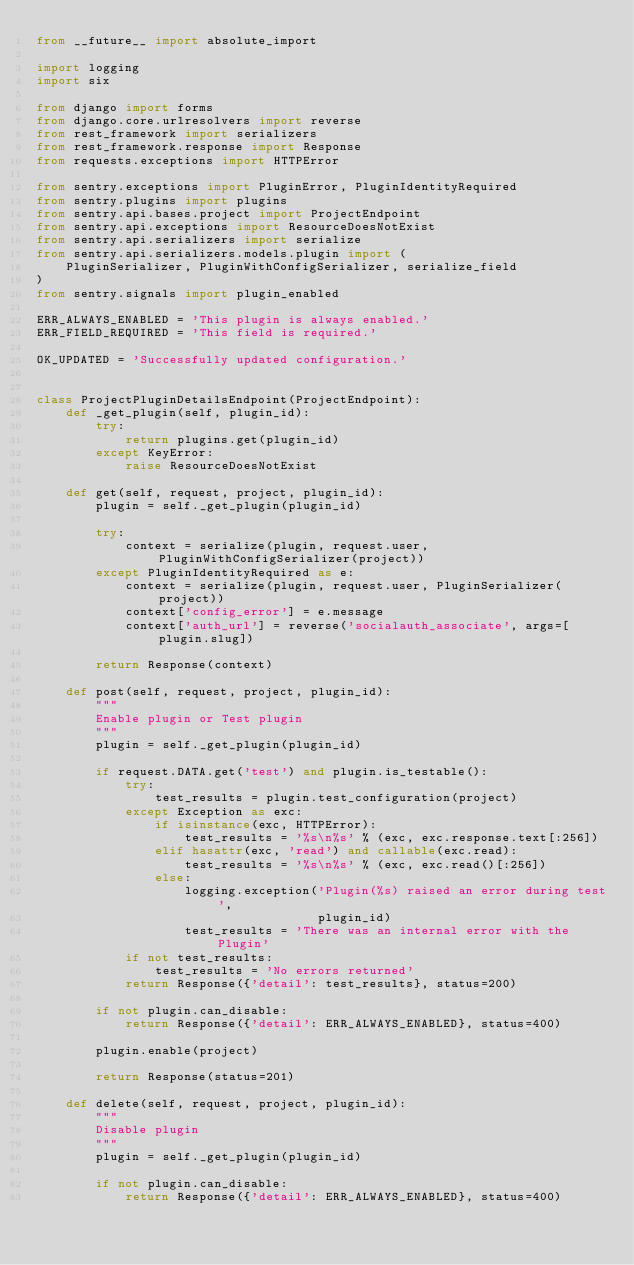<code> <loc_0><loc_0><loc_500><loc_500><_Python_>from __future__ import absolute_import

import logging
import six

from django import forms
from django.core.urlresolvers import reverse
from rest_framework import serializers
from rest_framework.response import Response
from requests.exceptions import HTTPError

from sentry.exceptions import PluginError, PluginIdentityRequired
from sentry.plugins import plugins
from sentry.api.bases.project import ProjectEndpoint
from sentry.api.exceptions import ResourceDoesNotExist
from sentry.api.serializers import serialize
from sentry.api.serializers.models.plugin import (
    PluginSerializer, PluginWithConfigSerializer, serialize_field
)
from sentry.signals import plugin_enabled

ERR_ALWAYS_ENABLED = 'This plugin is always enabled.'
ERR_FIELD_REQUIRED = 'This field is required.'

OK_UPDATED = 'Successfully updated configuration.'


class ProjectPluginDetailsEndpoint(ProjectEndpoint):
    def _get_plugin(self, plugin_id):
        try:
            return plugins.get(plugin_id)
        except KeyError:
            raise ResourceDoesNotExist

    def get(self, request, project, plugin_id):
        plugin = self._get_plugin(plugin_id)

        try:
            context = serialize(plugin, request.user, PluginWithConfigSerializer(project))
        except PluginIdentityRequired as e:
            context = serialize(plugin, request.user, PluginSerializer(project))
            context['config_error'] = e.message
            context['auth_url'] = reverse('socialauth_associate', args=[plugin.slug])

        return Response(context)

    def post(self, request, project, plugin_id):
        """
        Enable plugin or Test plugin
        """
        plugin = self._get_plugin(plugin_id)

        if request.DATA.get('test') and plugin.is_testable():
            try:
                test_results = plugin.test_configuration(project)
            except Exception as exc:
                if isinstance(exc, HTTPError):
                    test_results = '%s\n%s' % (exc, exc.response.text[:256])
                elif hasattr(exc, 'read') and callable(exc.read):
                    test_results = '%s\n%s' % (exc, exc.read()[:256])
                else:
                    logging.exception('Plugin(%s) raised an error during test',
                                      plugin_id)
                    test_results = 'There was an internal error with the Plugin'
            if not test_results:
                test_results = 'No errors returned'
            return Response({'detail': test_results}, status=200)

        if not plugin.can_disable:
            return Response({'detail': ERR_ALWAYS_ENABLED}, status=400)

        plugin.enable(project)

        return Response(status=201)

    def delete(self, request, project, plugin_id):
        """
        Disable plugin
        """
        plugin = self._get_plugin(plugin_id)

        if not plugin.can_disable:
            return Response({'detail': ERR_ALWAYS_ENABLED}, status=400)
</code> 